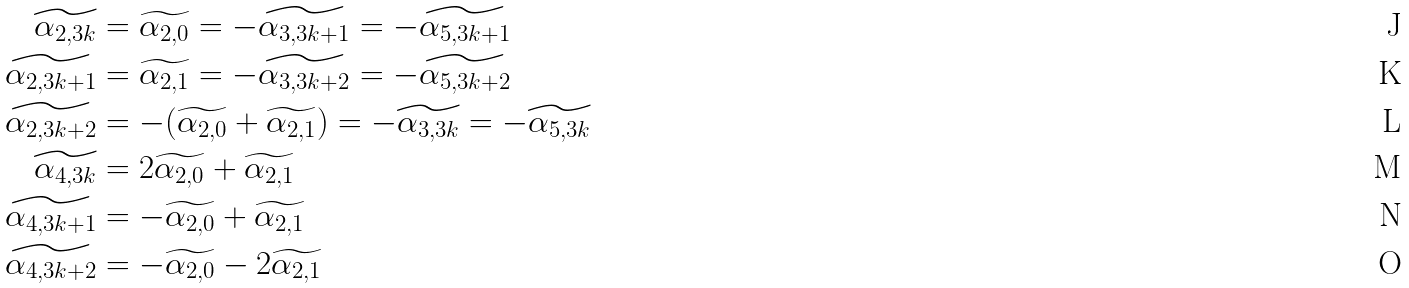<formula> <loc_0><loc_0><loc_500><loc_500>\widetilde { \alpha _ { 2 , 3 k } } & = \widetilde { \alpha _ { 2 , 0 } } = - \widetilde { \alpha _ { 3 , 3 k + 1 } } = - \widetilde { \alpha _ { 5 , 3 k + 1 } } \\ \widetilde { \alpha _ { 2 , 3 k + 1 } } & = \widetilde { \alpha _ { 2 , 1 } } = - \widetilde { \alpha _ { 3 , 3 k + 2 } } = - \widetilde { \alpha _ { 5 , 3 k + 2 } } \\ \widetilde { \alpha _ { 2 , 3 k + 2 } } & = - ( \widetilde { \alpha _ { 2 , 0 } } + \widetilde { \alpha _ { 2 , 1 } } ) = - \widetilde { \alpha _ { 3 , 3 k } } = - \widetilde { \alpha _ { 5 , 3 k } } \\ \widetilde { \alpha _ { 4 , 3 k } } & = 2 \widetilde { \alpha _ { 2 , 0 } } + \widetilde { \alpha _ { 2 , 1 } } \\ \widetilde { \alpha _ { 4 , 3 k + 1 } } & = - \widetilde { \alpha _ { 2 , 0 } } + \widetilde { \alpha _ { 2 , 1 } } \\ \widetilde { \alpha _ { 4 , 3 k + 2 } } & = - \widetilde { \alpha _ { 2 , 0 } } - 2 \widetilde { \alpha _ { 2 , 1 } }</formula> 